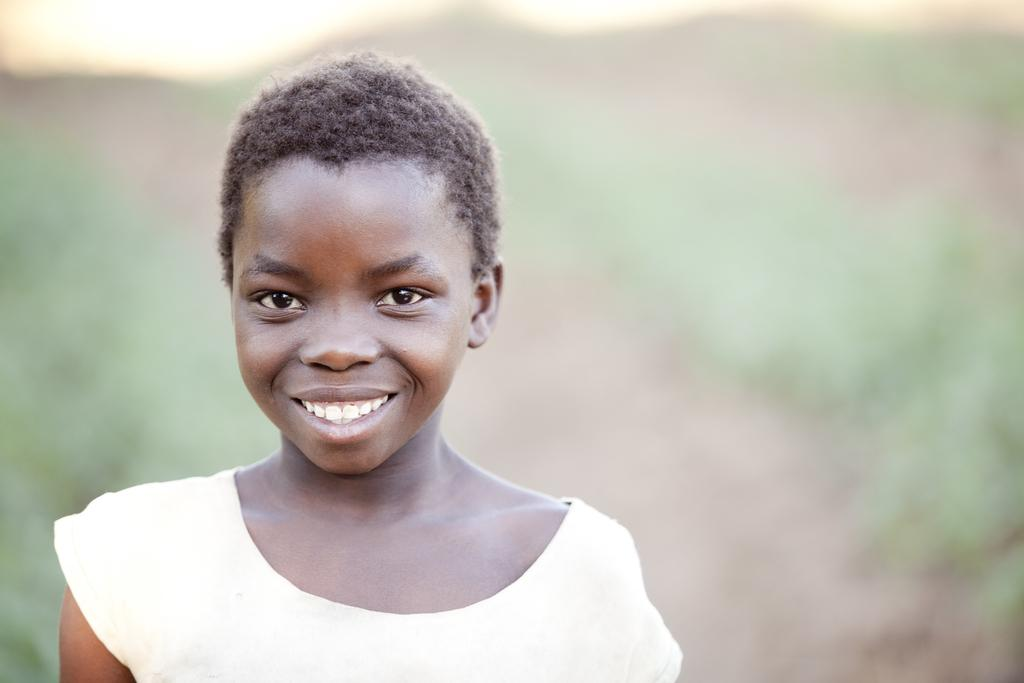What is the main subject of the image? The main subject of the image is a kid. What is the kid doing in the image? The kid is smiling in the image. Can you describe the background of the image? The background of the image is blurry. What type of string can be seen tied around the kid's finger in the image? There is no string tied around the kid's finger in the image. Is the kid holding a glass of milk in the image? There is no milk or glass visible in the image. 